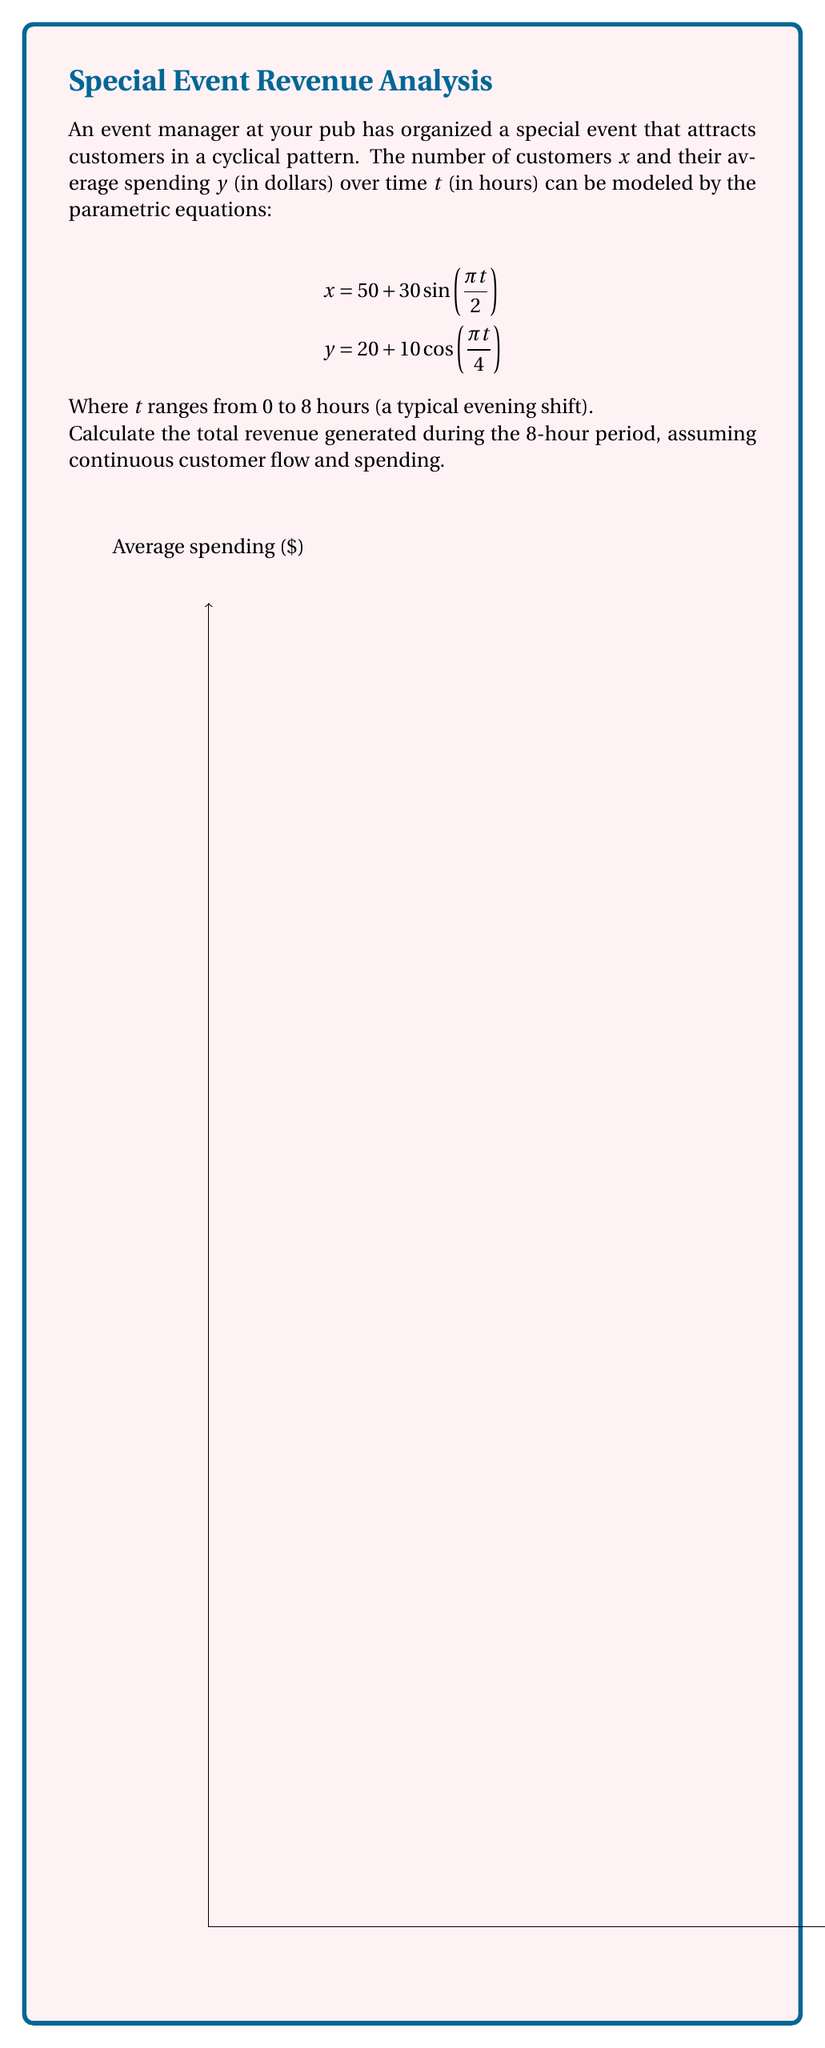Teach me how to tackle this problem. Let's approach this step-by-step:

1) The revenue at any given time $t$ is the product of the number of customers $x$ and their average spending $y$. We need to integrate this product over the 8-hour period.

2) The revenue function $R(t)$ is:
   $$R(t) = x(t) \cdot y(t) = (50 + 30\sin(\frac{\pi t}{2})) \cdot (20 + 10\cos(\frac{\pi t}{4}))$$

3) Expanding this:
   $$R(t) = 1000 + 500\sin(\frac{\pi t}{2}) + 600\cos(\frac{\pi t}{4}) + 300\sin(\frac{\pi t}{2})\cos(\frac{\pi t}{4})$$

4) The total revenue is the integral of $R(t)$ from $t=0$ to $t=8$:
   $$\text{Total Revenue} = \int_0^8 R(t) dt$$

5) Integrating each term:
   
   a) $\int_0^8 1000 dt = 8000$
   
   b) $\int_0^8 500\sin(\frac{\pi t}{2}) dt = -\frac{1000}{\pi}[\cos(\frac{\pi t}{2})]_0^8 = 0$
   
   c) $\int_0^8 600\cos(\frac{\pi t}{4}) dt = \frac{2400}{\pi}[\sin(\frac{\pi t}{4})]_0^8 = \frac{2400}{\pi} \cdot 2\sqrt{2} = \frac{4800\sqrt{2}}{\pi}$
   
   d) The last term is more complex and can be solved using trigonometric identities and integration by parts. Its integral over a full period (which 8 hours represents for both functions) is zero.

6) Adding up the non-zero terms:
   $$\text{Total Revenue} = 8000 + \frac{4800\sqrt{2}}{\pi} \approx 14,162.76$$

Therefore, the total revenue generated during the 8-hour period is approximately $14,162.76.
Answer: $8000 + \frac{4800\sqrt{2}}{\pi} \approx $14,162.76 